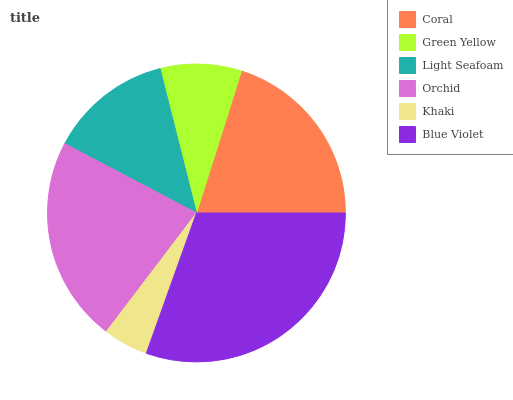Is Khaki the minimum?
Answer yes or no. Yes. Is Blue Violet the maximum?
Answer yes or no. Yes. Is Green Yellow the minimum?
Answer yes or no. No. Is Green Yellow the maximum?
Answer yes or no. No. Is Coral greater than Green Yellow?
Answer yes or no. Yes. Is Green Yellow less than Coral?
Answer yes or no. Yes. Is Green Yellow greater than Coral?
Answer yes or no. No. Is Coral less than Green Yellow?
Answer yes or no. No. Is Coral the high median?
Answer yes or no. Yes. Is Light Seafoam the low median?
Answer yes or no. Yes. Is Khaki the high median?
Answer yes or no. No. Is Coral the low median?
Answer yes or no. No. 